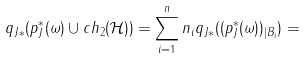<formula> <loc_0><loc_0><loc_500><loc_500>q _ { J * } ( p _ { J } ^ { * } ( \omega ) \cup c h _ { 2 } ( \mathcal { H } ) ) = \sum _ { i = 1 } ^ { n } n _ { i } q _ { J * } ( ( p _ { J } ^ { * } ( \omega ) ) _ { | B _ { i } } ) =</formula> 